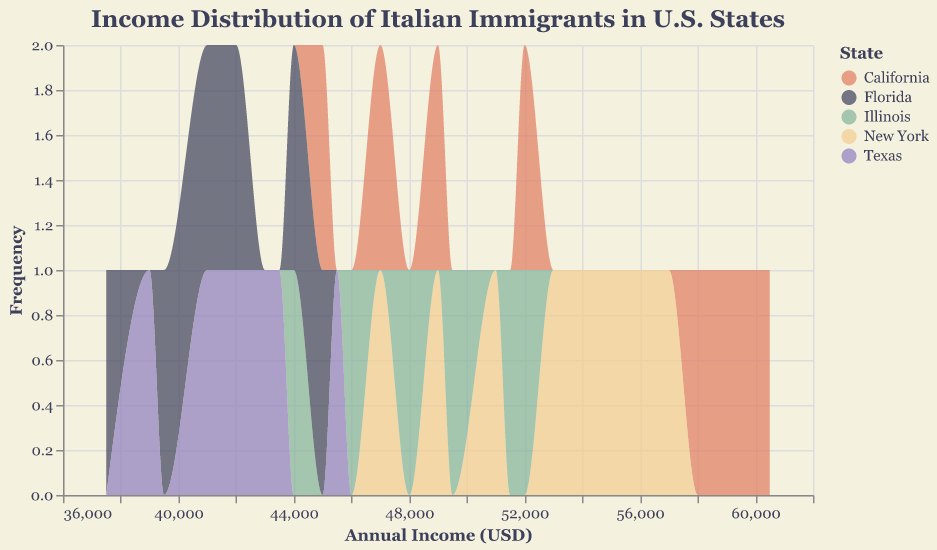What's the title of the plot? The title of the plot is located at the top of the figure. It reads "Income Distribution of Italian Immigrants in U.S. States".
Answer: Income Distribution of Italian Immigrants in U.S. States Which state shows the highest income frequency? By observing the plot, New York shows a dense cluster at frequencies around higher incomes compared to other states.
Answer: New York What is the income range for Texas? The income range can be determined by identifying the minimum and maximum income values plotted for Texas. The minimum is 39,000 and the maximum is 45,500.
Answer: $39,000 - $45,500 Compare the income distribution of California and Florida. Which state has a higher average income? By comparing the mean of entries for each state, California's incomes range higher with values like $60,500 and $58,000 compared to Florida's maximum of $44,000. Therefore, California has a higher average income.
Answer: California Which state has the lowest recorded income? By looking at the plotted values, the lowest income recorded is in Florida, at $37,500.
Answer: Florida How many unique data points are there for Illinois? By counting the individual income records for Illinois in the plot, we find a total of six data points.
Answer: 6 Considering the income distributions, which state appears to have the most evenly distributed incomes? Observing the spread of incomes across all states in the figure, Texas shows a fairly even spread across its range of incomes from $39,000 to $45,500.
Answer: Texas What can you infer about the skewness of the income distribution in New York? The distribution in New York shows a higher frequency of incomes at the upper end, suggesting a right skew.
Answer: Right skew What is the maximum income recorded for Illinois? By identifying the highest value plotted under Illinois, we see that the maximum income recorded is $52,000.
Answer: $52,000 Which state has a similar income distribution to Florida? Comparing the shapes and ranges of the distributions, Texas has an income distribution shape and range similar to that of Florida, with both states having lower ranges compared to others like California or New York.
Answer: Texas 